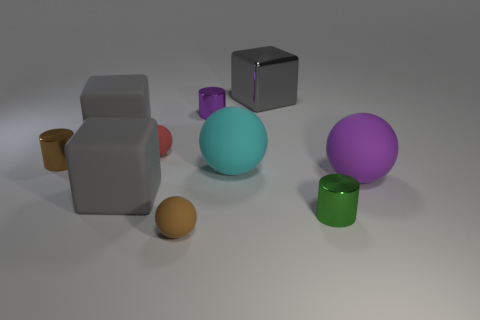Subtract all cubes. How many objects are left? 7 Subtract 1 red balls. How many objects are left? 9 Subtract all blue rubber blocks. Subtract all tiny shiny things. How many objects are left? 7 Add 5 small purple shiny things. How many small purple shiny things are left? 6 Add 7 tiny brown matte blocks. How many tiny brown matte blocks exist? 7 